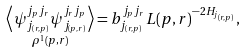Convert formula to latex. <formula><loc_0><loc_0><loc_500><loc_500>\underset { \rho ^ { 1 } ( p , r ) } { \left \langle \psi _ { j _ { ( r , p ) } } ^ { j _ { p } j _ { r } } \psi _ { j _ { ( p , r ) } } ^ { j _ { r } j _ { p } } \right \rangle } = b _ { j _ { ( r , p ) } } ^ { j _ { p } j _ { r } } L ( p , r ) ^ { - 2 H _ { j _ { ( r , p ) } } } ,</formula> 